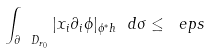<formula> <loc_0><loc_0><loc_500><loc_500>\int _ { \partial \ D _ { r _ { 0 } } } | x _ { i } \partial _ { i } \phi | _ { \phi ^ { * } h } \ d \sigma \leq \ e p s</formula> 